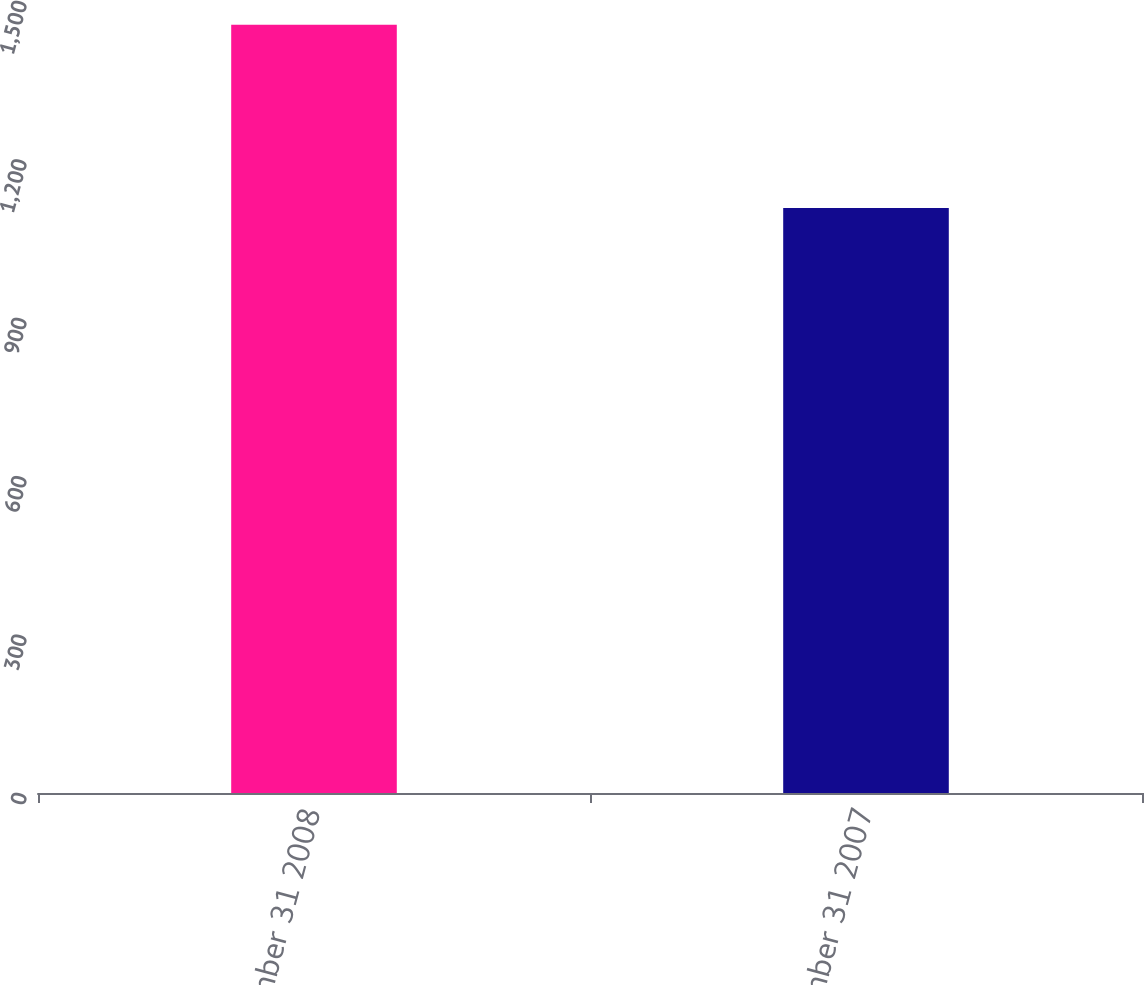Convert chart to OTSL. <chart><loc_0><loc_0><loc_500><loc_500><bar_chart><fcel>December 31 2008<fcel>December 31 2007<nl><fcel>1455<fcel>1108<nl></chart> 